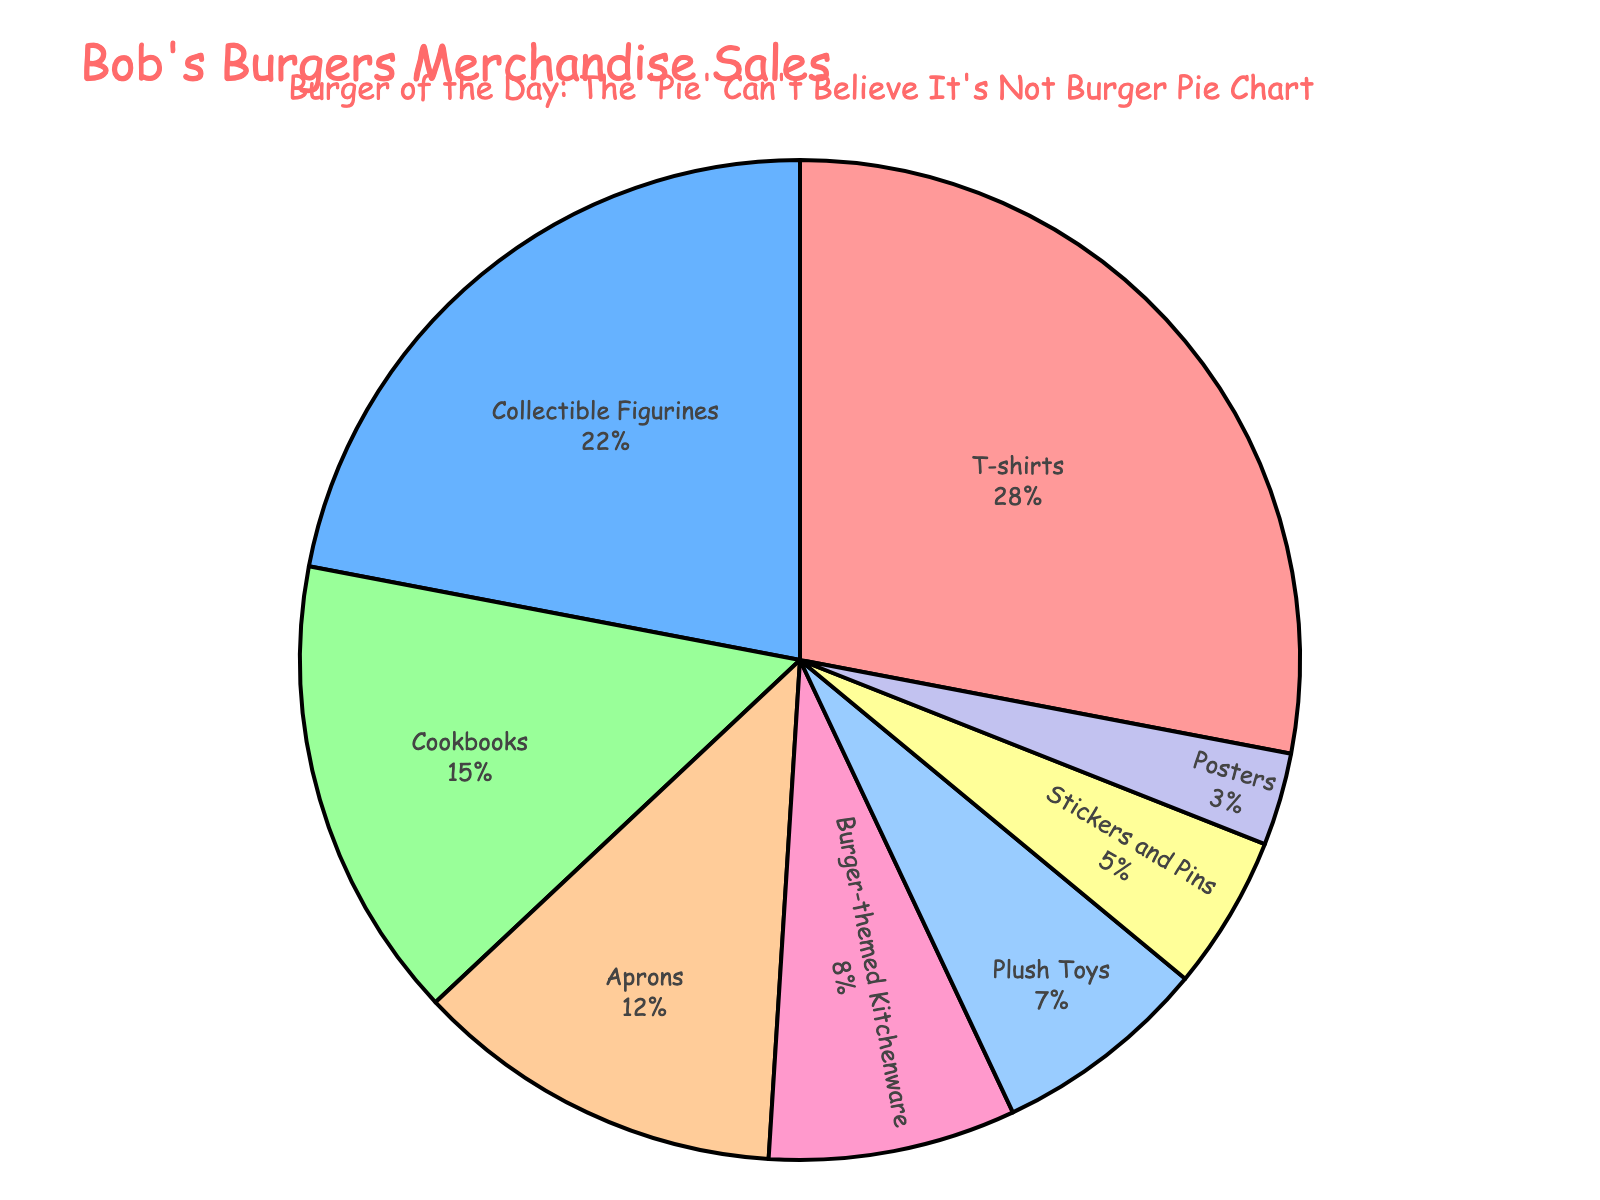What's the most sold product type for Bob's Burgers merchandise? Looking at the pie chart, the largest segment indicates the most sold product type. The T-shirts category is the largest.
Answer: T-shirts Which product type contributes the least to merchandise sales? The smallest pie chart segment represents the product type contributing the least. The Posters category is the smallest.
Answer: Posters How much more do T-shirts contribute to sales than Collectible Figurines? T-shirts have 28% and Collectible Figurines have 22%. The difference is 28% - 22% = 6%.
Answer: 6% What percentage of sales is made up by Kitchenware products (Cookbooks and Burger-themed Kitchenware)? Add the percentages for Cookbooks (15%) and Burger-themed Kitchenware (8%). 15% + 8% = 23%.
Answer: 23% Compare the sales contribution of Collectible Figurines and Plush Toys. Which one is higher and by how much? Collectible Figurines contribute 22% while Plush Toys contribute 7%. The difference is 22% - 7% = 15%.
Answer: Collectible Figurines by 15% What are the top three product types in terms of sales percentage? The top three segments by size are T-shirts (28%), Collectible Figurines (22%), and Cookbooks (15%).
Answer: T-shirts, Collectible Figurines, Cookbooks How do sales of Aprons compare to Plush Toys? Aprons contribute 12% while Plush Toys contribute 7%. Aprons have a higher contribution by 5%.
Answer: Aprons by 5% Which two product types together make up a quarter of total sales? Checking the combinations, Aprons (12%) and Burger-themed Kitchenware (8%) together make 20%, while Stickers and Pins (5%) and Posters (3%) together make 8%. The closest to a quarter are Collectible Figurines (22%) and Stickers and Pins (3%) totaling 25%.
Answer: Collectible Figurines and Stickers and Pins If we group all non-apparel items (i.e., everything except T-shirts and Aprons), what total percentage do they account for? Summing Collectible Figurines (22%), Cookbooks (15%), Burger-themed Kitchenware (8%), Plush Toys (7%), Stickers and Pins (5%), and Posters (3%): 22% + 15% + 8% + 7% + 5% + 3% = 60%.
Answer: 60% 